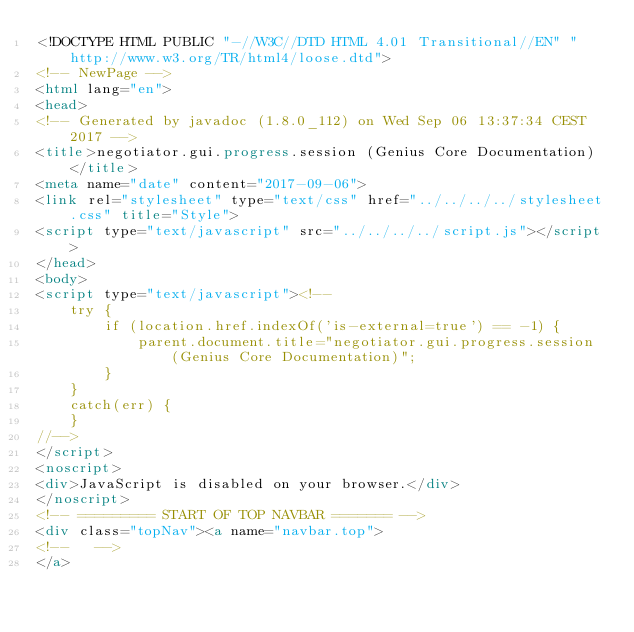Convert code to text. <code><loc_0><loc_0><loc_500><loc_500><_HTML_><!DOCTYPE HTML PUBLIC "-//W3C//DTD HTML 4.01 Transitional//EN" "http://www.w3.org/TR/html4/loose.dtd">
<!-- NewPage -->
<html lang="en">
<head>
<!-- Generated by javadoc (1.8.0_112) on Wed Sep 06 13:37:34 CEST 2017 -->
<title>negotiator.gui.progress.session (Genius Core Documentation)</title>
<meta name="date" content="2017-09-06">
<link rel="stylesheet" type="text/css" href="../../../../stylesheet.css" title="Style">
<script type="text/javascript" src="../../../../script.js"></script>
</head>
<body>
<script type="text/javascript"><!--
    try {
        if (location.href.indexOf('is-external=true') == -1) {
            parent.document.title="negotiator.gui.progress.session (Genius Core Documentation)";
        }
    }
    catch(err) {
    }
//-->
</script>
<noscript>
<div>JavaScript is disabled on your browser.</div>
</noscript>
<!-- ========= START OF TOP NAVBAR ======= -->
<div class="topNav"><a name="navbar.top">
<!--   -->
</a></code> 